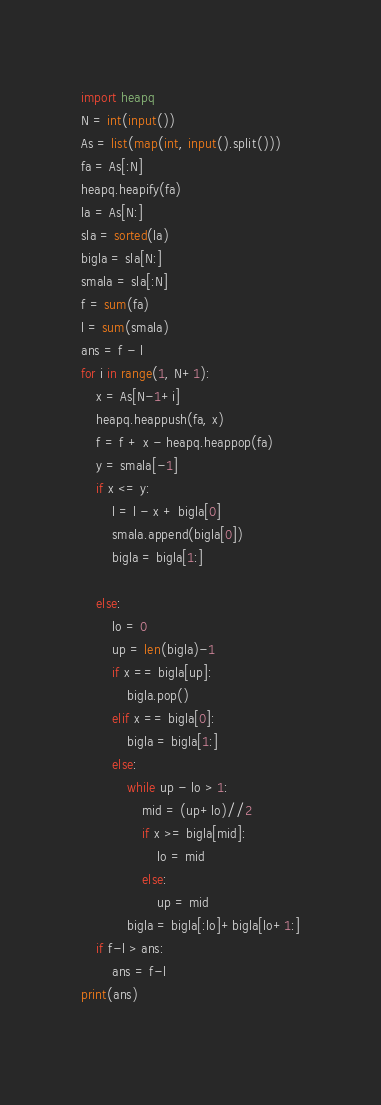<code> <loc_0><loc_0><loc_500><loc_500><_Python_>import heapq
N = int(input())
As = list(map(int, input().split()))
fa = As[:N]
heapq.heapify(fa)
la = As[N:]
sla = sorted(la)
bigla = sla[N:]
smala = sla[:N]
f = sum(fa)
l = sum(smala)
ans = f - l
for i in range(1, N+1):
    x = As[N-1+i]
    heapq.heappush(fa, x)
    f = f + x - heapq.heappop(fa)
    y = smala[-1]
    if x <= y:
        l = l - x + bigla[0]
        smala.append(bigla[0])
        bigla = bigla[1:]
       
    else:
        lo = 0
        up = len(bigla)-1
        if x == bigla[up]:
            bigla.pop()
        elif x == bigla[0]:
            bigla = bigla[1:]
        else:
            while up - lo > 1:
                mid = (up+lo)//2
                if x >= bigla[mid]:
                    lo = mid
                else:
                    up = mid
            bigla = bigla[:lo]+bigla[lo+1:]
    if f-l > ans:
        ans = f-l
print(ans)
    

</code> 